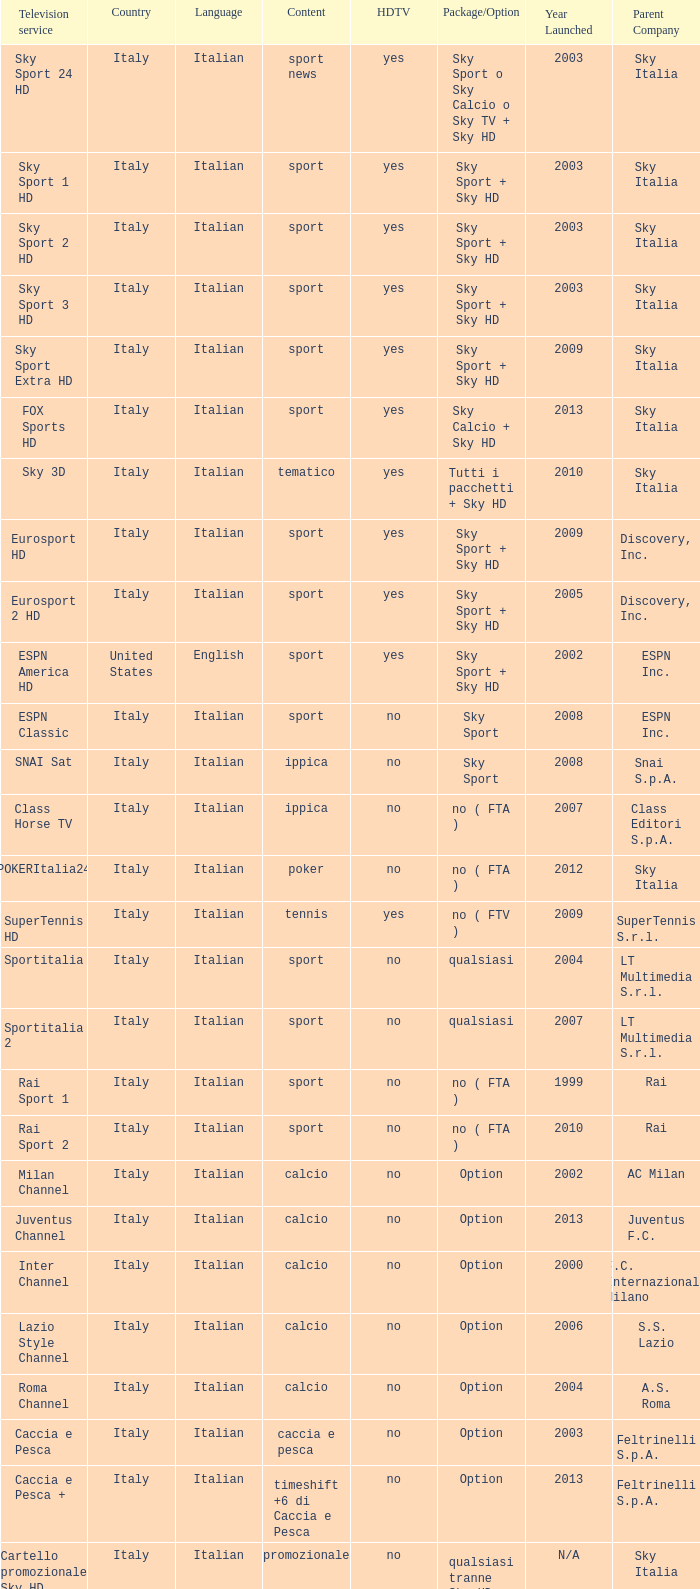What is Package/Option, when Content is Poker? No ( fta ). 